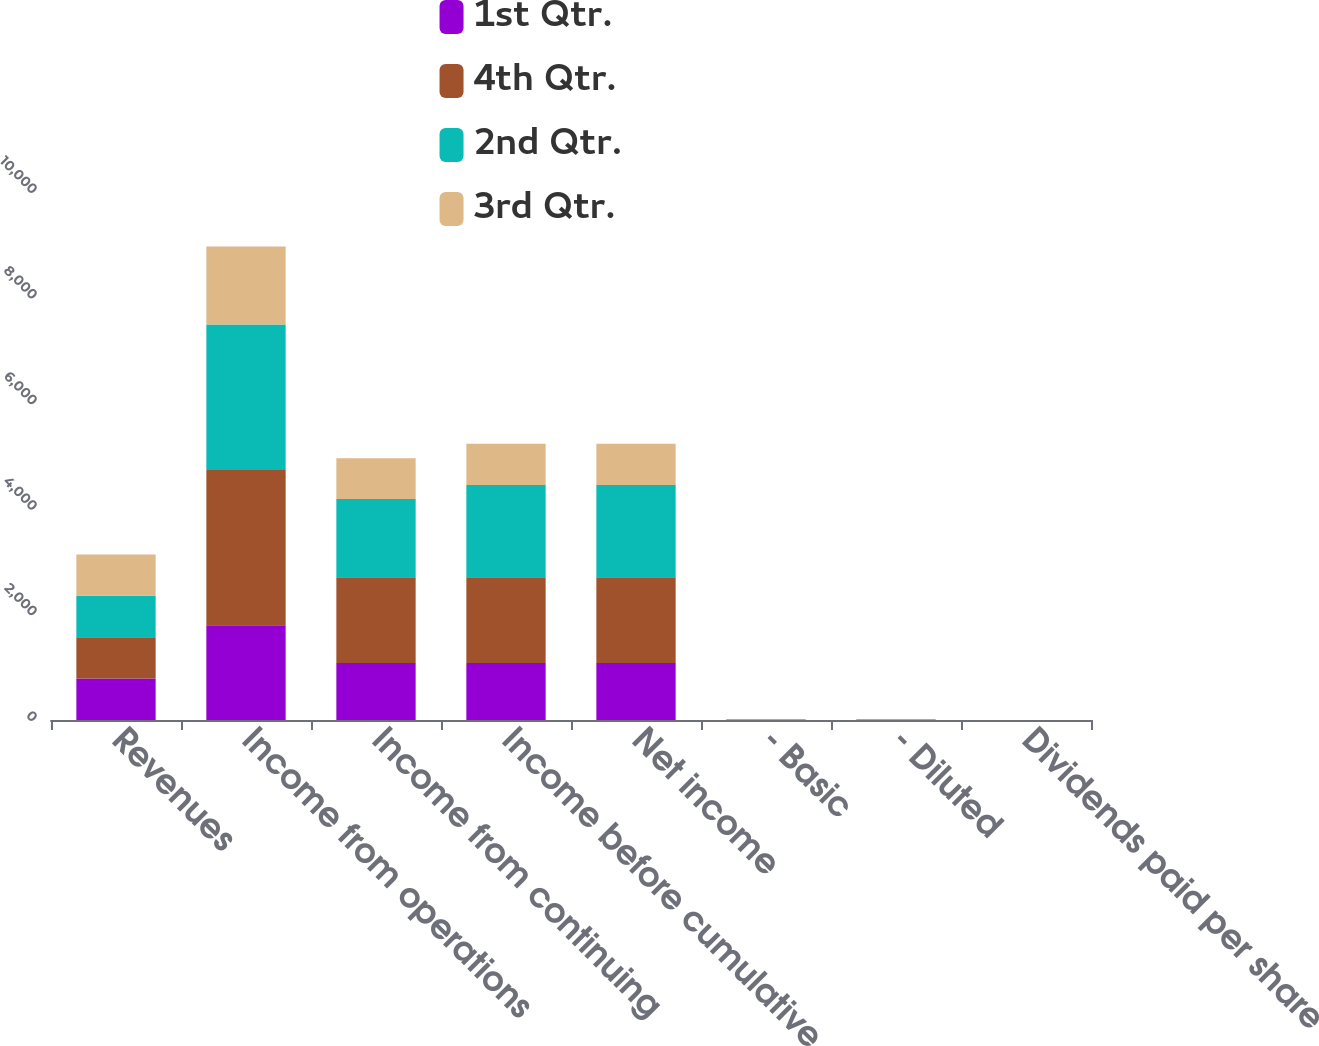Convert chart. <chart><loc_0><loc_0><loc_500><loc_500><stacked_bar_chart><ecel><fcel>Revenues<fcel>Income from operations<fcel>Income from continuing<fcel>Income before cumulative<fcel>Net income<fcel>- Basic<fcel>- Diluted<fcel>Dividends paid per share<nl><fcel>1st Qtr.<fcel>784<fcel>1793<fcel>1079<fcel>1079<fcel>1079<fcel>3.09<fcel>3.06<fcel>0.4<nl><fcel>4th Qtr.<fcel>784<fcel>2944<fcel>1623<fcel>1623<fcel>1623<fcel>4.55<fcel>4.52<fcel>0.4<nl><fcel>2nd Qtr.<fcel>784<fcel>2754<fcel>1484<fcel>1748<fcel>1748<fcel>4.84<fcel>4.8<fcel>0.4<nl><fcel>3rd Qtr.<fcel>784<fcel>1476<fcel>771<fcel>784<fcel>784<fcel>2.15<fcel>2.13<fcel>0.33<nl></chart> 